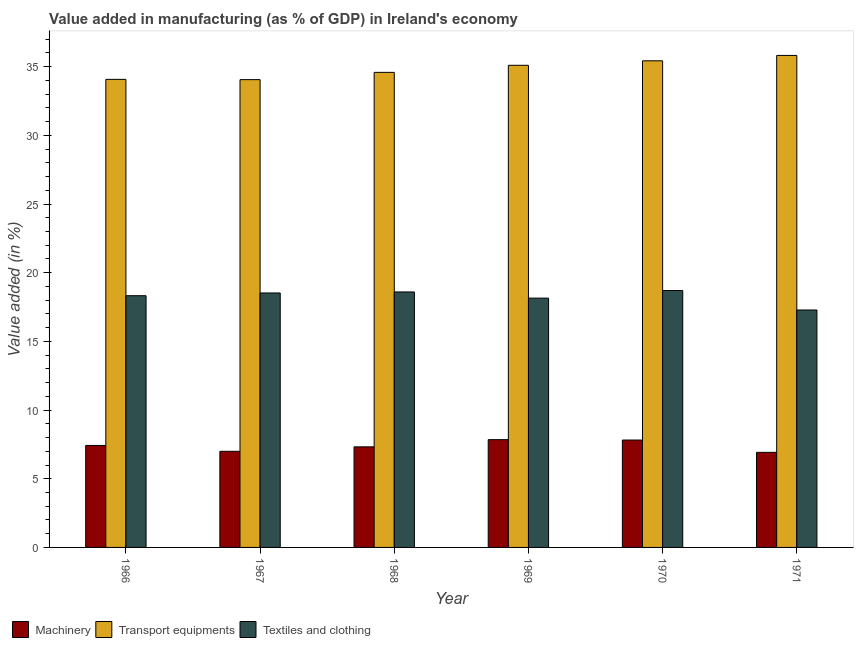Are the number of bars on each tick of the X-axis equal?
Your response must be concise. Yes. How many bars are there on the 1st tick from the right?
Make the answer very short. 3. What is the label of the 1st group of bars from the left?
Keep it short and to the point. 1966. In how many cases, is the number of bars for a given year not equal to the number of legend labels?
Keep it short and to the point. 0. What is the value added in manufacturing transport equipments in 1971?
Offer a terse response. 35.82. Across all years, what is the maximum value added in manufacturing transport equipments?
Give a very brief answer. 35.82. Across all years, what is the minimum value added in manufacturing textile and clothing?
Your answer should be compact. 17.29. In which year was the value added in manufacturing transport equipments maximum?
Ensure brevity in your answer.  1971. What is the total value added in manufacturing textile and clothing in the graph?
Your response must be concise. 109.59. What is the difference between the value added in manufacturing textile and clothing in 1968 and that in 1971?
Provide a succinct answer. 1.31. What is the difference between the value added in manufacturing textile and clothing in 1966 and the value added in manufacturing machinery in 1968?
Provide a succinct answer. -0.27. What is the average value added in manufacturing textile and clothing per year?
Make the answer very short. 18.27. In the year 1969, what is the difference between the value added in manufacturing machinery and value added in manufacturing textile and clothing?
Keep it short and to the point. 0. In how many years, is the value added in manufacturing transport equipments greater than 12 %?
Your answer should be very brief. 6. What is the ratio of the value added in manufacturing machinery in 1967 to that in 1970?
Offer a terse response. 0.9. Is the value added in manufacturing transport equipments in 1966 less than that in 1971?
Your answer should be compact. Yes. Is the difference between the value added in manufacturing transport equipments in 1968 and 1969 greater than the difference between the value added in manufacturing machinery in 1968 and 1969?
Your response must be concise. No. What is the difference between the highest and the second highest value added in manufacturing transport equipments?
Your response must be concise. 0.39. What is the difference between the highest and the lowest value added in manufacturing transport equipments?
Keep it short and to the point. 1.76. Is the sum of the value added in manufacturing transport equipments in 1966 and 1970 greater than the maximum value added in manufacturing machinery across all years?
Your response must be concise. Yes. What does the 1st bar from the left in 1966 represents?
Offer a terse response. Machinery. What does the 3rd bar from the right in 1970 represents?
Your answer should be compact. Machinery. Is it the case that in every year, the sum of the value added in manufacturing machinery and value added in manufacturing transport equipments is greater than the value added in manufacturing textile and clothing?
Ensure brevity in your answer.  Yes. How many years are there in the graph?
Offer a terse response. 6. Are the values on the major ticks of Y-axis written in scientific E-notation?
Give a very brief answer. No. Does the graph contain any zero values?
Your answer should be very brief. No. How many legend labels are there?
Your answer should be compact. 3. How are the legend labels stacked?
Offer a terse response. Horizontal. What is the title of the graph?
Your answer should be very brief. Value added in manufacturing (as % of GDP) in Ireland's economy. Does "Transport" appear as one of the legend labels in the graph?
Ensure brevity in your answer.  No. What is the label or title of the Y-axis?
Offer a terse response. Value added (in %). What is the Value added (in %) in Machinery in 1966?
Provide a short and direct response. 7.42. What is the Value added (in %) in Transport equipments in 1966?
Your response must be concise. 34.08. What is the Value added (in %) in Textiles and clothing in 1966?
Provide a short and direct response. 18.33. What is the Value added (in %) in Machinery in 1967?
Offer a terse response. 7. What is the Value added (in %) in Transport equipments in 1967?
Keep it short and to the point. 34.06. What is the Value added (in %) of Textiles and clothing in 1967?
Provide a short and direct response. 18.53. What is the Value added (in %) of Machinery in 1968?
Offer a very short reply. 7.32. What is the Value added (in %) of Transport equipments in 1968?
Your answer should be compact. 34.59. What is the Value added (in %) of Textiles and clothing in 1968?
Offer a very short reply. 18.6. What is the Value added (in %) of Machinery in 1969?
Offer a very short reply. 7.85. What is the Value added (in %) of Transport equipments in 1969?
Provide a succinct answer. 35.1. What is the Value added (in %) of Textiles and clothing in 1969?
Keep it short and to the point. 18.15. What is the Value added (in %) of Machinery in 1970?
Ensure brevity in your answer.  7.82. What is the Value added (in %) in Transport equipments in 1970?
Your response must be concise. 35.43. What is the Value added (in %) in Textiles and clothing in 1970?
Offer a terse response. 18.7. What is the Value added (in %) in Machinery in 1971?
Offer a terse response. 6.92. What is the Value added (in %) of Transport equipments in 1971?
Your response must be concise. 35.82. What is the Value added (in %) of Textiles and clothing in 1971?
Give a very brief answer. 17.29. Across all years, what is the maximum Value added (in %) of Machinery?
Give a very brief answer. 7.85. Across all years, what is the maximum Value added (in %) of Transport equipments?
Your answer should be compact. 35.82. Across all years, what is the maximum Value added (in %) of Textiles and clothing?
Give a very brief answer. 18.7. Across all years, what is the minimum Value added (in %) in Machinery?
Keep it short and to the point. 6.92. Across all years, what is the minimum Value added (in %) in Transport equipments?
Provide a succinct answer. 34.06. Across all years, what is the minimum Value added (in %) of Textiles and clothing?
Provide a succinct answer. 17.29. What is the total Value added (in %) of Machinery in the graph?
Keep it short and to the point. 44.33. What is the total Value added (in %) of Transport equipments in the graph?
Ensure brevity in your answer.  209.07. What is the total Value added (in %) of Textiles and clothing in the graph?
Your answer should be very brief. 109.59. What is the difference between the Value added (in %) in Machinery in 1966 and that in 1967?
Keep it short and to the point. 0.43. What is the difference between the Value added (in %) in Transport equipments in 1966 and that in 1967?
Provide a short and direct response. 0.02. What is the difference between the Value added (in %) in Textiles and clothing in 1966 and that in 1967?
Offer a terse response. -0.2. What is the difference between the Value added (in %) in Machinery in 1966 and that in 1968?
Offer a terse response. 0.1. What is the difference between the Value added (in %) in Transport equipments in 1966 and that in 1968?
Offer a terse response. -0.51. What is the difference between the Value added (in %) in Textiles and clothing in 1966 and that in 1968?
Your response must be concise. -0.27. What is the difference between the Value added (in %) in Machinery in 1966 and that in 1969?
Your response must be concise. -0.42. What is the difference between the Value added (in %) of Transport equipments in 1966 and that in 1969?
Ensure brevity in your answer.  -1.02. What is the difference between the Value added (in %) in Textiles and clothing in 1966 and that in 1969?
Provide a short and direct response. 0.17. What is the difference between the Value added (in %) of Machinery in 1966 and that in 1970?
Give a very brief answer. -0.39. What is the difference between the Value added (in %) of Transport equipments in 1966 and that in 1970?
Provide a succinct answer. -1.35. What is the difference between the Value added (in %) of Textiles and clothing in 1966 and that in 1970?
Keep it short and to the point. -0.38. What is the difference between the Value added (in %) in Machinery in 1966 and that in 1971?
Make the answer very short. 0.5. What is the difference between the Value added (in %) in Transport equipments in 1966 and that in 1971?
Make the answer very short. -1.74. What is the difference between the Value added (in %) in Textiles and clothing in 1966 and that in 1971?
Ensure brevity in your answer.  1.04. What is the difference between the Value added (in %) in Machinery in 1967 and that in 1968?
Make the answer very short. -0.32. What is the difference between the Value added (in %) of Transport equipments in 1967 and that in 1968?
Give a very brief answer. -0.53. What is the difference between the Value added (in %) of Textiles and clothing in 1967 and that in 1968?
Offer a terse response. -0.08. What is the difference between the Value added (in %) of Machinery in 1967 and that in 1969?
Your answer should be compact. -0.85. What is the difference between the Value added (in %) in Transport equipments in 1967 and that in 1969?
Offer a terse response. -1.04. What is the difference between the Value added (in %) of Textiles and clothing in 1967 and that in 1969?
Keep it short and to the point. 0.37. What is the difference between the Value added (in %) of Machinery in 1967 and that in 1970?
Keep it short and to the point. -0.82. What is the difference between the Value added (in %) of Transport equipments in 1967 and that in 1970?
Keep it short and to the point. -1.37. What is the difference between the Value added (in %) of Textiles and clothing in 1967 and that in 1970?
Your answer should be compact. -0.18. What is the difference between the Value added (in %) in Machinery in 1967 and that in 1971?
Offer a terse response. 0.08. What is the difference between the Value added (in %) of Transport equipments in 1967 and that in 1971?
Offer a very short reply. -1.76. What is the difference between the Value added (in %) of Textiles and clothing in 1967 and that in 1971?
Your answer should be very brief. 1.24. What is the difference between the Value added (in %) of Machinery in 1968 and that in 1969?
Give a very brief answer. -0.52. What is the difference between the Value added (in %) in Transport equipments in 1968 and that in 1969?
Your response must be concise. -0.52. What is the difference between the Value added (in %) in Textiles and clothing in 1968 and that in 1969?
Make the answer very short. 0.45. What is the difference between the Value added (in %) in Machinery in 1968 and that in 1970?
Provide a short and direct response. -0.5. What is the difference between the Value added (in %) of Transport equipments in 1968 and that in 1970?
Your response must be concise. -0.84. What is the difference between the Value added (in %) of Textiles and clothing in 1968 and that in 1970?
Provide a short and direct response. -0.1. What is the difference between the Value added (in %) of Machinery in 1968 and that in 1971?
Your response must be concise. 0.4. What is the difference between the Value added (in %) of Transport equipments in 1968 and that in 1971?
Give a very brief answer. -1.23. What is the difference between the Value added (in %) of Textiles and clothing in 1968 and that in 1971?
Provide a succinct answer. 1.31. What is the difference between the Value added (in %) of Machinery in 1969 and that in 1970?
Make the answer very short. 0.03. What is the difference between the Value added (in %) of Transport equipments in 1969 and that in 1970?
Give a very brief answer. -0.33. What is the difference between the Value added (in %) of Textiles and clothing in 1969 and that in 1970?
Offer a terse response. -0.55. What is the difference between the Value added (in %) of Machinery in 1969 and that in 1971?
Your answer should be compact. 0.92. What is the difference between the Value added (in %) of Transport equipments in 1969 and that in 1971?
Provide a succinct answer. -0.72. What is the difference between the Value added (in %) of Textiles and clothing in 1969 and that in 1971?
Offer a very short reply. 0.86. What is the difference between the Value added (in %) of Machinery in 1970 and that in 1971?
Provide a short and direct response. 0.89. What is the difference between the Value added (in %) in Transport equipments in 1970 and that in 1971?
Offer a very short reply. -0.39. What is the difference between the Value added (in %) of Textiles and clothing in 1970 and that in 1971?
Ensure brevity in your answer.  1.42. What is the difference between the Value added (in %) in Machinery in 1966 and the Value added (in %) in Transport equipments in 1967?
Keep it short and to the point. -26.63. What is the difference between the Value added (in %) in Machinery in 1966 and the Value added (in %) in Textiles and clothing in 1967?
Offer a very short reply. -11.1. What is the difference between the Value added (in %) of Transport equipments in 1966 and the Value added (in %) of Textiles and clothing in 1967?
Ensure brevity in your answer.  15.55. What is the difference between the Value added (in %) in Machinery in 1966 and the Value added (in %) in Transport equipments in 1968?
Your answer should be compact. -27.16. What is the difference between the Value added (in %) of Machinery in 1966 and the Value added (in %) of Textiles and clothing in 1968?
Ensure brevity in your answer.  -11.18. What is the difference between the Value added (in %) of Transport equipments in 1966 and the Value added (in %) of Textiles and clothing in 1968?
Your response must be concise. 15.48. What is the difference between the Value added (in %) of Machinery in 1966 and the Value added (in %) of Transport equipments in 1969?
Provide a short and direct response. -27.68. What is the difference between the Value added (in %) of Machinery in 1966 and the Value added (in %) of Textiles and clothing in 1969?
Ensure brevity in your answer.  -10.73. What is the difference between the Value added (in %) of Transport equipments in 1966 and the Value added (in %) of Textiles and clothing in 1969?
Provide a succinct answer. 15.93. What is the difference between the Value added (in %) of Machinery in 1966 and the Value added (in %) of Transport equipments in 1970?
Your answer should be very brief. -28. What is the difference between the Value added (in %) in Machinery in 1966 and the Value added (in %) in Textiles and clothing in 1970?
Offer a very short reply. -11.28. What is the difference between the Value added (in %) in Transport equipments in 1966 and the Value added (in %) in Textiles and clothing in 1970?
Make the answer very short. 15.37. What is the difference between the Value added (in %) in Machinery in 1966 and the Value added (in %) in Transport equipments in 1971?
Ensure brevity in your answer.  -28.4. What is the difference between the Value added (in %) in Machinery in 1966 and the Value added (in %) in Textiles and clothing in 1971?
Your answer should be compact. -9.86. What is the difference between the Value added (in %) of Transport equipments in 1966 and the Value added (in %) of Textiles and clothing in 1971?
Keep it short and to the point. 16.79. What is the difference between the Value added (in %) in Machinery in 1967 and the Value added (in %) in Transport equipments in 1968?
Provide a short and direct response. -27.59. What is the difference between the Value added (in %) of Machinery in 1967 and the Value added (in %) of Textiles and clothing in 1968?
Keep it short and to the point. -11.6. What is the difference between the Value added (in %) of Transport equipments in 1967 and the Value added (in %) of Textiles and clothing in 1968?
Provide a succinct answer. 15.46. What is the difference between the Value added (in %) of Machinery in 1967 and the Value added (in %) of Transport equipments in 1969?
Your answer should be very brief. -28.1. What is the difference between the Value added (in %) of Machinery in 1967 and the Value added (in %) of Textiles and clothing in 1969?
Your response must be concise. -11.15. What is the difference between the Value added (in %) of Transport equipments in 1967 and the Value added (in %) of Textiles and clothing in 1969?
Provide a succinct answer. 15.91. What is the difference between the Value added (in %) of Machinery in 1967 and the Value added (in %) of Transport equipments in 1970?
Give a very brief answer. -28.43. What is the difference between the Value added (in %) of Machinery in 1967 and the Value added (in %) of Textiles and clothing in 1970?
Provide a succinct answer. -11.71. What is the difference between the Value added (in %) in Transport equipments in 1967 and the Value added (in %) in Textiles and clothing in 1970?
Your response must be concise. 15.35. What is the difference between the Value added (in %) in Machinery in 1967 and the Value added (in %) in Transport equipments in 1971?
Give a very brief answer. -28.82. What is the difference between the Value added (in %) of Machinery in 1967 and the Value added (in %) of Textiles and clothing in 1971?
Offer a very short reply. -10.29. What is the difference between the Value added (in %) in Transport equipments in 1967 and the Value added (in %) in Textiles and clothing in 1971?
Your response must be concise. 16.77. What is the difference between the Value added (in %) of Machinery in 1968 and the Value added (in %) of Transport equipments in 1969?
Ensure brevity in your answer.  -27.78. What is the difference between the Value added (in %) of Machinery in 1968 and the Value added (in %) of Textiles and clothing in 1969?
Provide a succinct answer. -10.83. What is the difference between the Value added (in %) in Transport equipments in 1968 and the Value added (in %) in Textiles and clothing in 1969?
Your answer should be very brief. 16.44. What is the difference between the Value added (in %) in Machinery in 1968 and the Value added (in %) in Transport equipments in 1970?
Make the answer very short. -28.11. What is the difference between the Value added (in %) of Machinery in 1968 and the Value added (in %) of Textiles and clothing in 1970?
Give a very brief answer. -11.38. What is the difference between the Value added (in %) in Transport equipments in 1968 and the Value added (in %) in Textiles and clothing in 1970?
Provide a succinct answer. 15.88. What is the difference between the Value added (in %) of Machinery in 1968 and the Value added (in %) of Transport equipments in 1971?
Provide a short and direct response. -28.5. What is the difference between the Value added (in %) in Machinery in 1968 and the Value added (in %) in Textiles and clothing in 1971?
Give a very brief answer. -9.96. What is the difference between the Value added (in %) of Transport equipments in 1968 and the Value added (in %) of Textiles and clothing in 1971?
Provide a short and direct response. 17.3. What is the difference between the Value added (in %) in Machinery in 1969 and the Value added (in %) in Transport equipments in 1970?
Your answer should be compact. -27.58. What is the difference between the Value added (in %) of Machinery in 1969 and the Value added (in %) of Textiles and clothing in 1970?
Offer a very short reply. -10.86. What is the difference between the Value added (in %) of Transport equipments in 1969 and the Value added (in %) of Textiles and clothing in 1970?
Your answer should be very brief. 16.4. What is the difference between the Value added (in %) in Machinery in 1969 and the Value added (in %) in Transport equipments in 1971?
Offer a terse response. -27.97. What is the difference between the Value added (in %) in Machinery in 1969 and the Value added (in %) in Textiles and clothing in 1971?
Your response must be concise. -9.44. What is the difference between the Value added (in %) in Transport equipments in 1969 and the Value added (in %) in Textiles and clothing in 1971?
Offer a very short reply. 17.81. What is the difference between the Value added (in %) of Machinery in 1970 and the Value added (in %) of Transport equipments in 1971?
Your answer should be very brief. -28. What is the difference between the Value added (in %) in Machinery in 1970 and the Value added (in %) in Textiles and clothing in 1971?
Offer a very short reply. -9.47. What is the difference between the Value added (in %) in Transport equipments in 1970 and the Value added (in %) in Textiles and clothing in 1971?
Your answer should be very brief. 18.14. What is the average Value added (in %) of Machinery per year?
Your response must be concise. 7.39. What is the average Value added (in %) of Transport equipments per year?
Keep it short and to the point. 34.85. What is the average Value added (in %) of Textiles and clothing per year?
Offer a terse response. 18.27. In the year 1966, what is the difference between the Value added (in %) in Machinery and Value added (in %) in Transport equipments?
Give a very brief answer. -26.65. In the year 1966, what is the difference between the Value added (in %) of Machinery and Value added (in %) of Textiles and clothing?
Provide a short and direct response. -10.9. In the year 1966, what is the difference between the Value added (in %) in Transport equipments and Value added (in %) in Textiles and clothing?
Provide a succinct answer. 15.75. In the year 1967, what is the difference between the Value added (in %) in Machinery and Value added (in %) in Transport equipments?
Your answer should be very brief. -27.06. In the year 1967, what is the difference between the Value added (in %) of Machinery and Value added (in %) of Textiles and clothing?
Provide a short and direct response. -11.53. In the year 1967, what is the difference between the Value added (in %) of Transport equipments and Value added (in %) of Textiles and clothing?
Provide a short and direct response. 15.53. In the year 1968, what is the difference between the Value added (in %) of Machinery and Value added (in %) of Transport equipments?
Ensure brevity in your answer.  -27.26. In the year 1968, what is the difference between the Value added (in %) in Machinery and Value added (in %) in Textiles and clothing?
Ensure brevity in your answer.  -11.28. In the year 1968, what is the difference between the Value added (in %) of Transport equipments and Value added (in %) of Textiles and clothing?
Your answer should be very brief. 15.99. In the year 1969, what is the difference between the Value added (in %) of Machinery and Value added (in %) of Transport equipments?
Give a very brief answer. -27.25. In the year 1969, what is the difference between the Value added (in %) in Machinery and Value added (in %) in Textiles and clothing?
Your answer should be very brief. -10.3. In the year 1969, what is the difference between the Value added (in %) in Transport equipments and Value added (in %) in Textiles and clothing?
Make the answer very short. 16.95. In the year 1970, what is the difference between the Value added (in %) in Machinery and Value added (in %) in Transport equipments?
Provide a succinct answer. -27.61. In the year 1970, what is the difference between the Value added (in %) in Machinery and Value added (in %) in Textiles and clothing?
Ensure brevity in your answer.  -10.89. In the year 1970, what is the difference between the Value added (in %) of Transport equipments and Value added (in %) of Textiles and clothing?
Ensure brevity in your answer.  16.72. In the year 1971, what is the difference between the Value added (in %) of Machinery and Value added (in %) of Transport equipments?
Your answer should be very brief. -28.9. In the year 1971, what is the difference between the Value added (in %) of Machinery and Value added (in %) of Textiles and clothing?
Provide a short and direct response. -10.36. In the year 1971, what is the difference between the Value added (in %) of Transport equipments and Value added (in %) of Textiles and clothing?
Ensure brevity in your answer.  18.53. What is the ratio of the Value added (in %) in Machinery in 1966 to that in 1967?
Your answer should be compact. 1.06. What is the ratio of the Value added (in %) in Textiles and clothing in 1966 to that in 1967?
Provide a short and direct response. 0.99. What is the ratio of the Value added (in %) of Machinery in 1966 to that in 1968?
Give a very brief answer. 1.01. What is the ratio of the Value added (in %) in Transport equipments in 1966 to that in 1968?
Make the answer very short. 0.99. What is the ratio of the Value added (in %) in Textiles and clothing in 1966 to that in 1968?
Give a very brief answer. 0.99. What is the ratio of the Value added (in %) of Machinery in 1966 to that in 1969?
Provide a succinct answer. 0.95. What is the ratio of the Value added (in %) of Transport equipments in 1966 to that in 1969?
Make the answer very short. 0.97. What is the ratio of the Value added (in %) in Textiles and clothing in 1966 to that in 1969?
Keep it short and to the point. 1.01. What is the ratio of the Value added (in %) of Machinery in 1966 to that in 1970?
Ensure brevity in your answer.  0.95. What is the ratio of the Value added (in %) in Transport equipments in 1966 to that in 1970?
Ensure brevity in your answer.  0.96. What is the ratio of the Value added (in %) in Textiles and clothing in 1966 to that in 1970?
Your answer should be very brief. 0.98. What is the ratio of the Value added (in %) of Machinery in 1966 to that in 1971?
Provide a succinct answer. 1.07. What is the ratio of the Value added (in %) in Transport equipments in 1966 to that in 1971?
Offer a terse response. 0.95. What is the ratio of the Value added (in %) in Textiles and clothing in 1966 to that in 1971?
Your answer should be compact. 1.06. What is the ratio of the Value added (in %) of Machinery in 1967 to that in 1968?
Make the answer very short. 0.96. What is the ratio of the Value added (in %) of Transport equipments in 1967 to that in 1968?
Give a very brief answer. 0.98. What is the ratio of the Value added (in %) of Textiles and clothing in 1967 to that in 1968?
Your answer should be very brief. 1. What is the ratio of the Value added (in %) in Machinery in 1967 to that in 1969?
Provide a succinct answer. 0.89. What is the ratio of the Value added (in %) in Transport equipments in 1967 to that in 1969?
Your answer should be compact. 0.97. What is the ratio of the Value added (in %) of Textiles and clothing in 1967 to that in 1969?
Make the answer very short. 1.02. What is the ratio of the Value added (in %) in Machinery in 1967 to that in 1970?
Provide a succinct answer. 0.9. What is the ratio of the Value added (in %) of Transport equipments in 1967 to that in 1970?
Your answer should be compact. 0.96. What is the ratio of the Value added (in %) in Textiles and clothing in 1967 to that in 1970?
Give a very brief answer. 0.99. What is the ratio of the Value added (in %) in Machinery in 1967 to that in 1971?
Offer a very short reply. 1.01. What is the ratio of the Value added (in %) in Transport equipments in 1967 to that in 1971?
Offer a very short reply. 0.95. What is the ratio of the Value added (in %) of Textiles and clothing in 1967 to that in 1971?
Offer a terse response. 1.07. What is the ratio of the Value added (in %) in Machinery in 1968 to that in 1969?
Make the answer very short. 0.93. What is the ratio of the Value added (in %) in Transport equipments in 1968 to that in 1969?
Provide a short and direct response. 0.99. What is the ratio of the Value added (in %) of Textiles and clothing in 1968 to that in 1969?
Ensure brevity in your answer.  1.02. What is the ratio of the Value added (in %) in Machinery in 1968 to that in 1970?
Your answer should be very brief. 0.94. What is the ratio of the Value added (in %) in Transport equipments in 1968 to that in 1970?
Give a very brief answer. 0.98. What is the ratio of the Value added (in %) in Machinery in 1968 to that in 1971?
Ensure brevity in your answer.  1.06. What is the ratio of the Value added (in %) in Transport equipments in 1968 to that in 1971?
Give a very brief answer. 0.97. What is the ratio of the Value added (in %) in Textiles and clothing in 1968 to that in 1971?
Your answer should be very brief. 1.08. What is the ratio of the Value added (in %) of Transport equipments in 1969 to that in 1970?
Make the answer very short. 0.99. What is the ratio of the Value added (in %) in Textiles and clothing in 1969 to that in 1970?
Your response must be concise. 0.97. What is the ratio of the Value added (in %) in Machinery in 1969 to that in 1971?
Give a very brief answer. 1.13. What is the ratio of the Value added (in %) in Transport equipments in 1969 to that in 1971?
Provide a succinct answer. 0.98. What is the ratio of the Value added (in %) in Machinery in 1970 to that in 1971?
Make the answer very short. 1.13. What is the ratio of the Value added (in %) in Transport equipments in 1970 to that in 1971?
Your answer should be compact. 0.99. What is the ratio of the Value added (in %) in Textiles and clothing in 1970 to that in 1971?
Offer a terse response. 1.08. What is the difference between the highest and the second highest Value added (in %) in Machinery?
Provide a succinct answer. 0.03. What is the difference between the highest and the second highest Value added (in %) of Transport equipments?
Your answer should be very brief. 0.39. What is the difference between the highest and the second highest Value added (in %) of Textiles and clothing?
Make the answer very short. 0.1. What is the difference between the highest and the lowest Value added (in %) in Machinery?
Offer a terse response. 0.92. What is the difference between the highest and the lowest Value added (in %) of Transport equipments?
Your response must be concise. 1.76. What is the difference between the highest and the lowest Value added (in %) of Textiles and clothing?
Provide a short and direct response. 1.42. 